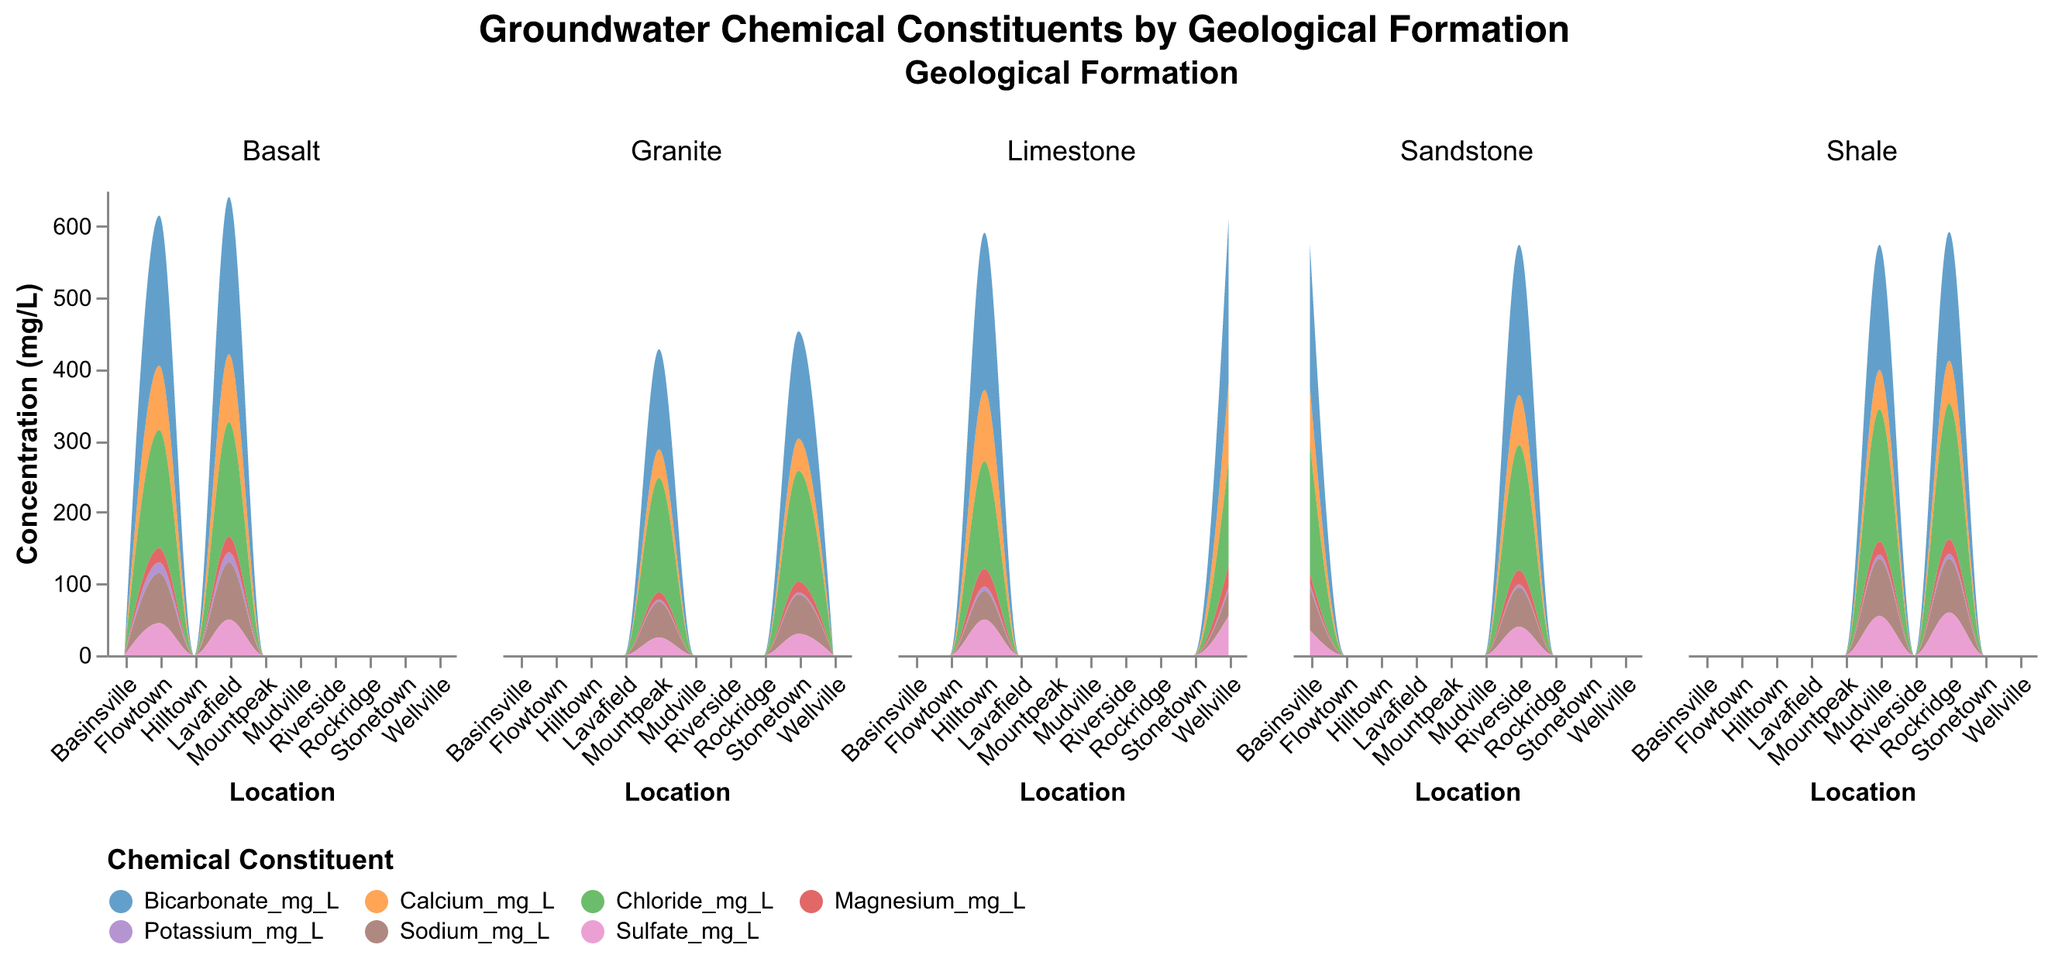What is the title of the figure? The title of the chart is displayed at the top and reads "Groundwater Chemical Constituents by Geological Formation"
Answer: Groundwater Chemical Constituents by Geological Formation What are the geological formations represented in the figure? The geological formations are shown in the column headers as "Sandstone", "Limestone", "Shale", "Granite", and "Basalt"
Answer: Sandstone, Limestone, Shale, Granite, Basalt Which geological formation has the highest concentration of Calcium at any location? By looking at the area charts for each formation, Limestone at Wellville shows the highest peak in Calcium concentration
Answer: Limestone at Wellville What is the total concentration of all chemical constituents in Sandstone formations at Basinsville? Sum up the concentrations of all chemical constituents in Sandstone at Basinsville: Calcium (80) + Sodium (60) + Potassium (5) + Magnesium (15) + Bicarbonate (200) + Chloride (180) + Sulfate (35) = 575 mg/L
Answer: 575 mg/L Compare the Sodium concentration in Sandstone at Basinsville and Shale at Mudville. Which is higher? Refer to the charts for Sodium concentrations at the specified locations: Sandstone (Basinsville) is 60 mg/L, Shale (Mudville) is 80 mg/L. Mudville has a higher concentration
Answer: Shale at Mudville Which chemical constituent has the least variation across different geological formations? By comparing the individual charts and noting the range of high and low points for each chemical: Potassium (3-7 mg/L) shows the least variation across formations
Answer: Potassium How does the concentration of Bicarbonate change between Granite at Mountpeak and Basalt at Flowtown? Compare the Bicarbonate concentrations directly: Granite (Mountpeak) is 140 mg/L, Basalt (Flowtown) is 210 mg/L. There is an increase of 70 mg/L from Granite to Basalt
Answer: Increases by 70 mg/L Which location shows the lowest concentration of Magnesium? Check the Magnesium values across all locations: Granite at Mountpeak has the lowest concentration of 10 mg/L
Answer: Granite at Mountpeak What is the average Chloride concentration in Limestone formations? Sum Chloride concentrations in Limestone (Hilltown: 150, Wellville: 145) and divide by the number of locations: (150 + 145) / 2 = 147.5 mg/L
Answer: 147.5 mg/L In which location within the Basalt formation is the Sulfate concentration higher? Within the Basalt formation, compare Flowtown (45 mg/L) and Lavafield (50 mg/L): Lavafield has the higher concentration
Answer: Lavafield 